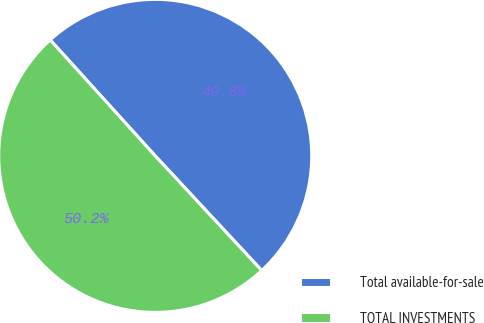Convert chart. <chart><loc_0><loc_0><loc_500><loc_500><pie_chart><fcel>Total available-for-sale<fcel>TOTAL INVESTMENTS<nl><fcel>49.8%<fcel>50.2%<nl></chart> 